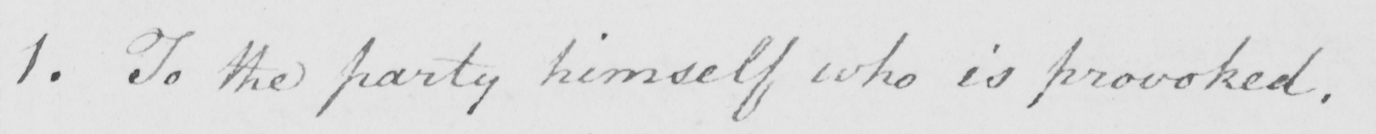What is written in this line of handwriting? 1. To the party himself who is provoked. 